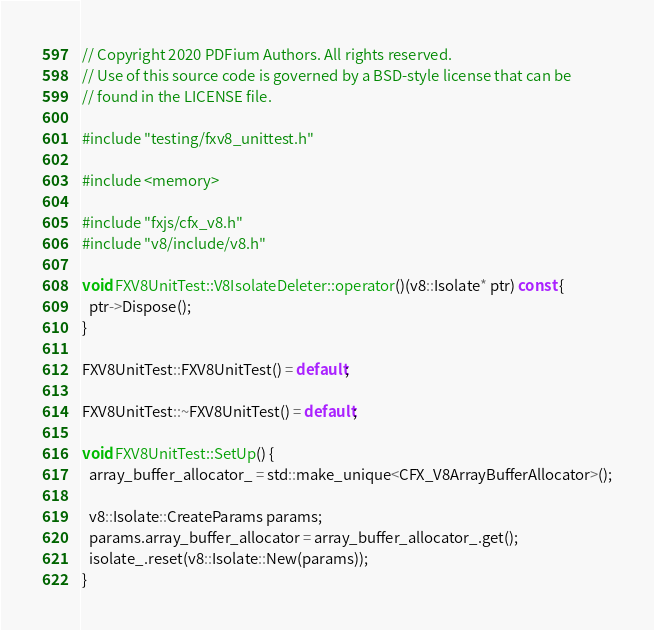<code> <loc_0><loc_0><loc_500><loc_500><_C++_>// Copyright 2020 PDFium Authors. All rights reserved.
// Use of this source code is governed by a BSD-style license that can be
// found in the LICENSE file.

#include "testing/fxv8_unittest.h"

#include <memory>

#include "fxjs/cfx_v8.h"
#include "v8/include/v8.h"

void FXV8UnitTest::V8IsolateDeleter::operator()(v8::Isolate* ptr) const {
  ptr->Dispose();
}

FXV8UnitTest::FXV8UnitTest() = default;

FXV8UnitTest::~FXV8UnitTest() = default;

void FXV8UnitTest::SetUp() {
  array_buffer_allocator_ = std::make_unique<CFX_V8ArrayBufferAllocator>();

  v8::Isolate::CreateParams params;
  params.array_buffer_allocator = array_buffer_allocator_.get();
  isolate_.reset(v8::Isolate::New(params));
}
</code> 